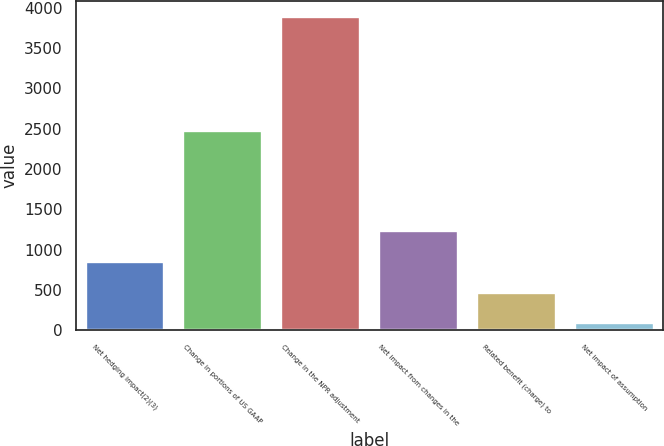Convert chart. <chart><loc_0><loc_0><loc_500><loc_500><bar_chart><fcel>Net hedging impact(2)(3)<fcel>Change in portions of US GAAP<fcel>Change in the NPR adjustment<fcel>Net impact from changes in the<fcel>Related benefit (charge) to<fcel>Net impact of assumption<nl><fcel>846<fcel>2477<fcel>3890<fcel>1226.5<fcel>465.5<fcel>85<nl></chart> 